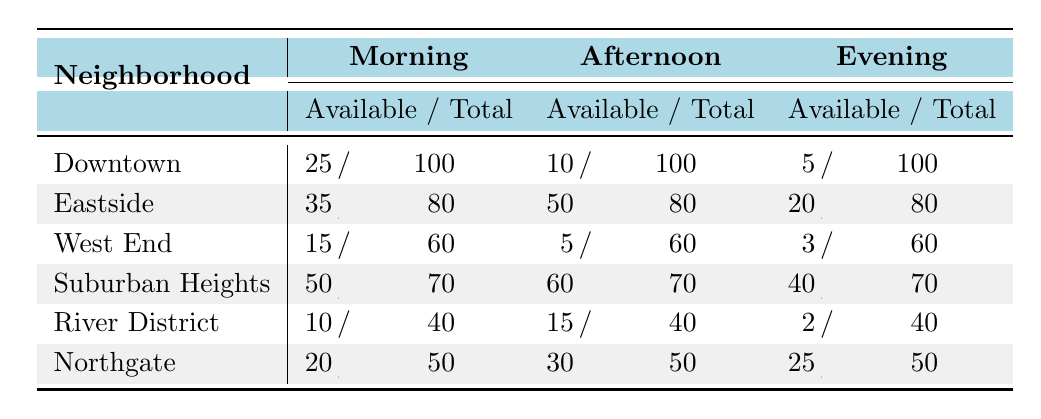What is the total number of parking slots available in Downtown during the Morning? The table indicates that there are 25 available slots out of 100 total slots in Downtown during the Morning. Therefore, the total number of parking slots available is 25.
Answer: 25 Which neighborhood has the highest amount of available parking slots in the Afternoon? By examining the Afternoon row, Eastside has 50 available slots, which is the highest compared to other neighborhoods.
Answer: Eastside What is the overall percentage of available parking slots in Suburban Heights during the Evening? In the Evening, Suburban Heights has 40 available slots out of 70 total slots. To find the percentage, (40 / 70) * 100 = 57.14%.
Answer: 57.14% How many more parking slots are available in the Morning than in the Evening for the West End neighborhood? The West End has 15 available parking slots in the Morning and 3 in the Evening. The difference is 15 - 3 = 12.
Answer: 12 Is it true that the River District has more slots available in the Afternoon than in the Morning? In the Afternoon, the River District has 15 available slots, which is more than the 10 available slots in the Morning. Therefore, the statement is true.
Answer: Yes What is the total number of available parking slots summed across all neighborhoods in the Evening? Summing the Evening available slots for all neighborhoods: 5 (Downtown) + 20 (Eastside) + 3 (West End) + 40 (Suburban Heights) + 2 (River District) + 25 (Northgate) = 95.
Answer: 95 What is the average number of available parking slots during the Morning across all neighborhoods? The Morning available slots are 25 (Downtown), 35 (Eastside), 15 (West End), 50 (Suburban Heights), 10 (River District), and 20 (Northgate). The total is 25 + 35 + 15 + 50 + 10 + 20 = 155. There are 6 neighborhoods, so the average is 155 / 6 = 25.83.
Answer: 25.83 Which neighborhood has consistently low parking availability throughout the day? By reviewing the available slots in each time block, West End has 15 (Morning), 5 (Afternoon), and 3 (Evening), indicating consistently low availability.
Answer: West End What is the difference in the number of available parking slots between Suburban Heights and River District in the Afternoon? Suburban Heights has 60 available slots, while the River District has 15. The difference is 60 - 15 = 45.
Answer: 45 In which time of day does Northgate experience the highest parking availability? In the Evening, Northgate has 25 available slots, which is the highest compared to 20 in the Morning and 30 in the Afternoon. Therefore, it has the highest availability in the Evening.
Answer: Evening 